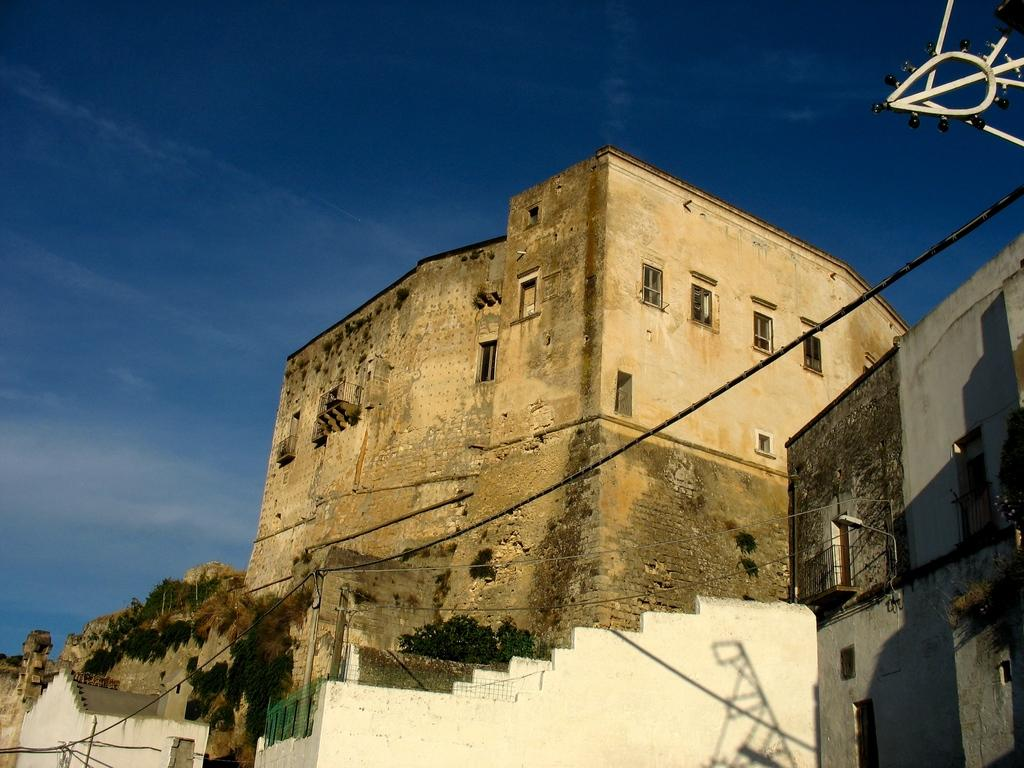What type of structure is the main subject in the image? There is an old building in the image. What is the purpose of the old building? The old building appears to be a monument. Are there any other structures visible in the image? Yes, there is a house beside the old building. Can you see a woman carrying a tray in the image? There is no woman carrying a tray in the image. What type of church is depicted in the image? There is no church present in the image; it features an old building that appears to be a monument. 